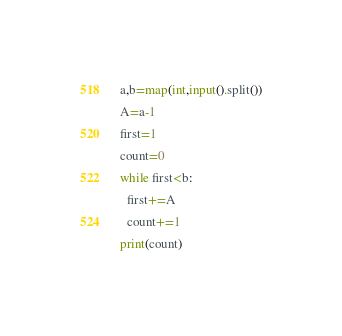<code> <loc_0><loc_0><loc_500><loc_500><_Python_>a,b=map(int,input().split())
A=a-1
first=1
count=0
while first<b:
  first+=A
  count+=1
print(count)
</code> 